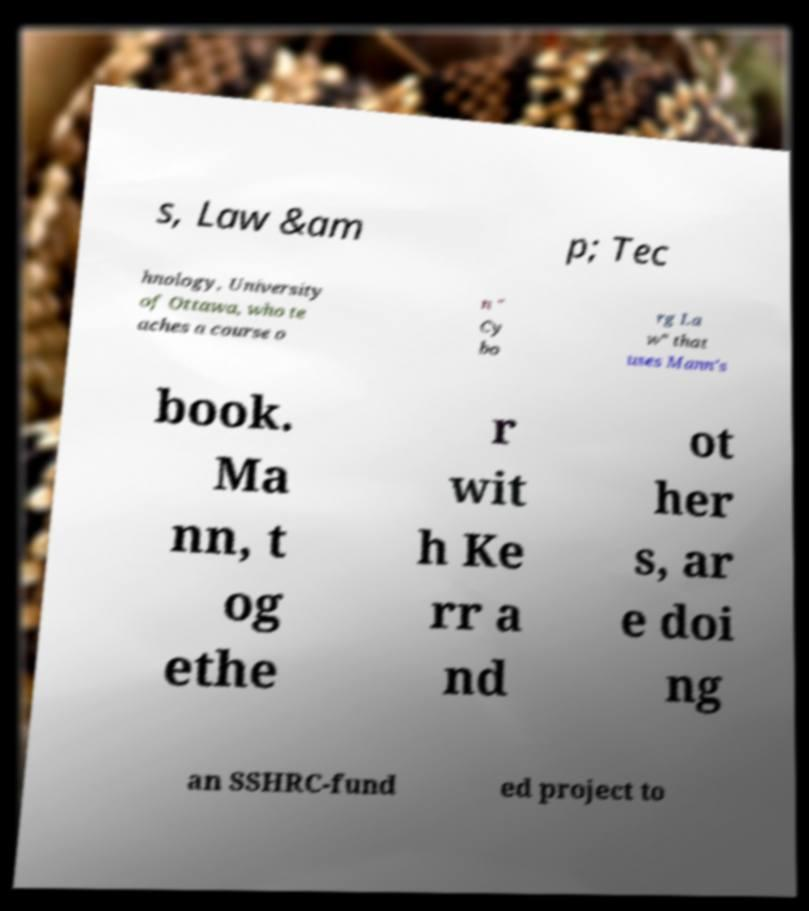I need the written content from this picture converted into text. Can you do that? s, Law &am p; Tec hnology, University of Ottawa, who te aches a course o n " Cy bo rg La w" that uses Mann's book. Ma nn, t og ethe r wit h Ke rr a nd ot her s, ar e doi ng an SSHRC-fund ed project to 